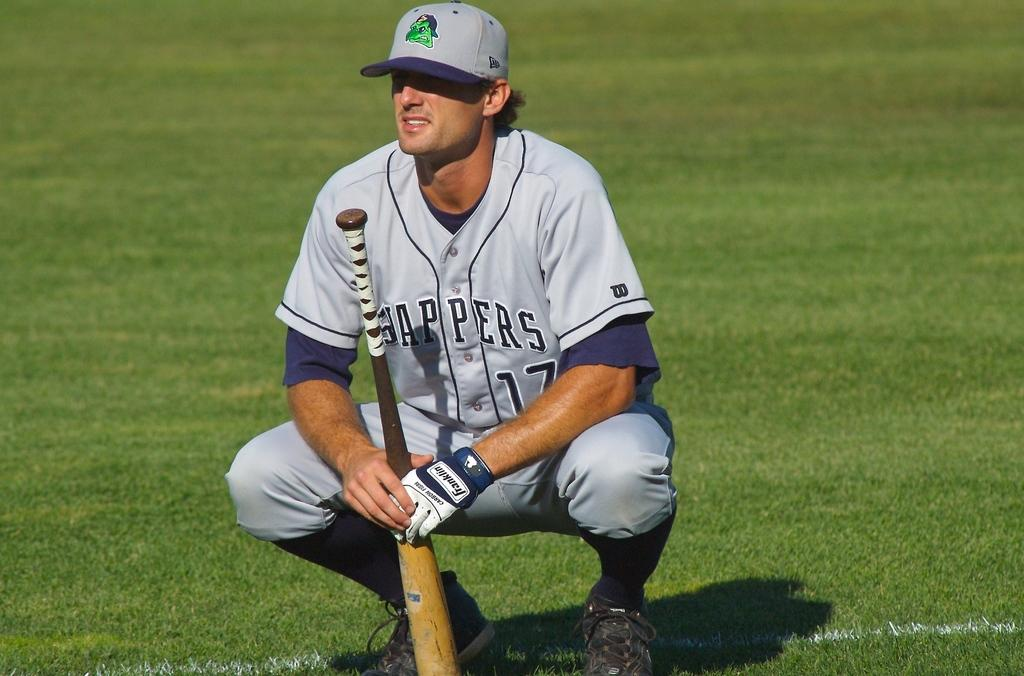Provide a one-sentence caption for the provided image. A baseball playyer with the number 17 on his outfit. 